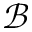<formula> <loc_0><loc_0><loc_500><loc_500>\mathcal { B }</formula> 